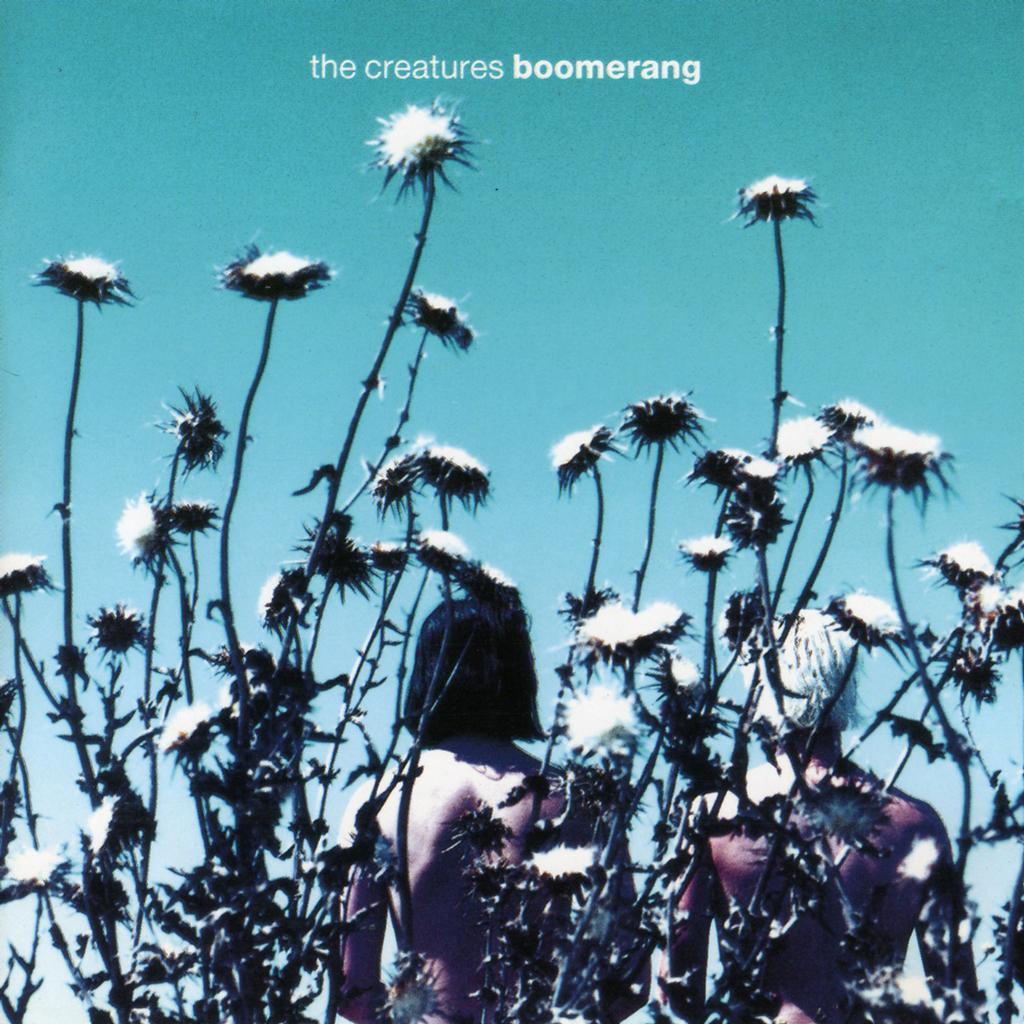How would you summarize this image in a sentence or two? In the picture I can see trees with flowers. In the background, I can see two persons. At the top of the image I can see some written text. 